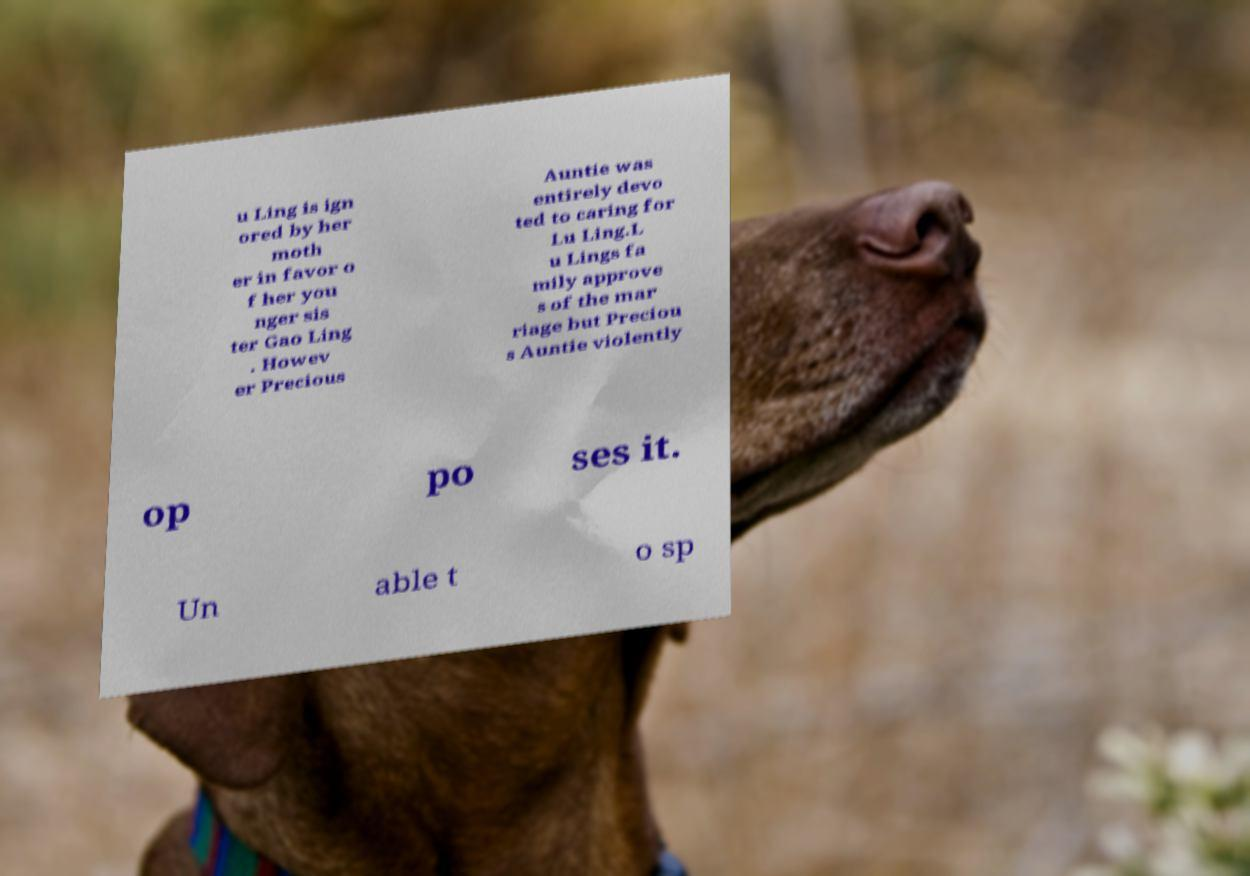For documentation purposes, I need the text within this image transcribed. Could you provide that? u Ling is ign ored by her moth er in favor o f her you nger sis ter Gao Ling . Howev er Precious Auntie was entirely devo ted to caring for Lu Ling.L u Lings fa mily approve s of the mar riage but Preciou s Auntie violently op po ses it. Un able t o sp 